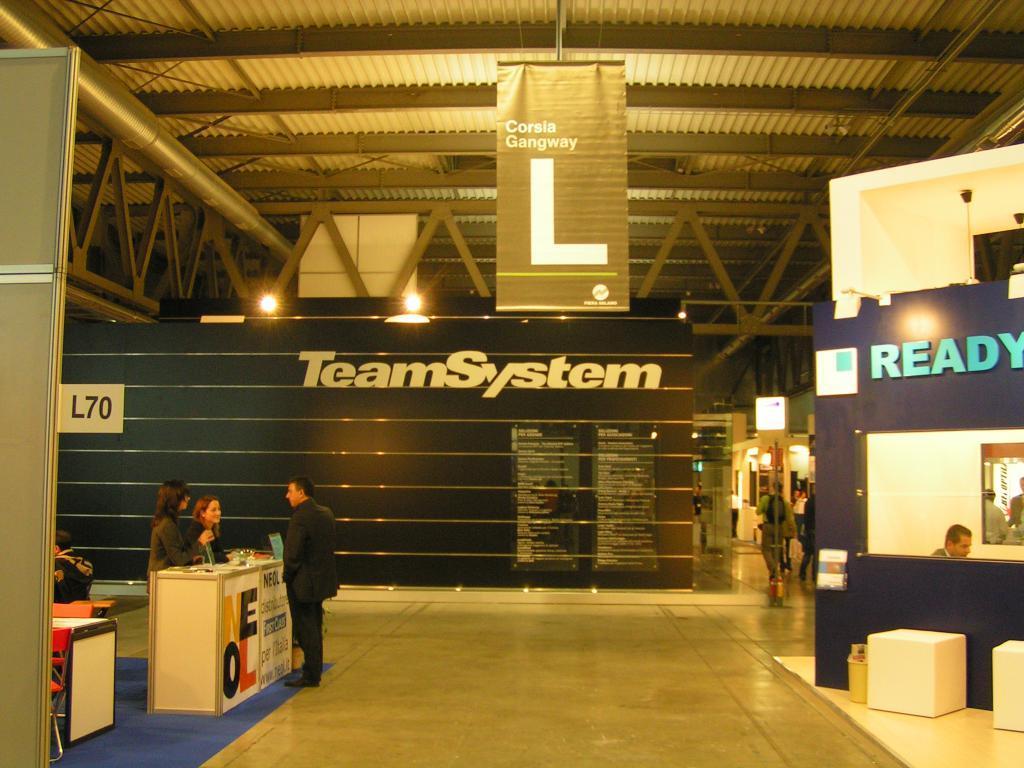Can you describe this image briefly? In this image I can see the floor, a table, few persons standing around the table, few chairs, the black colored wall, few boards, a banner, the ceiling, few metal rods, few lights and few other persons standing in the background. 